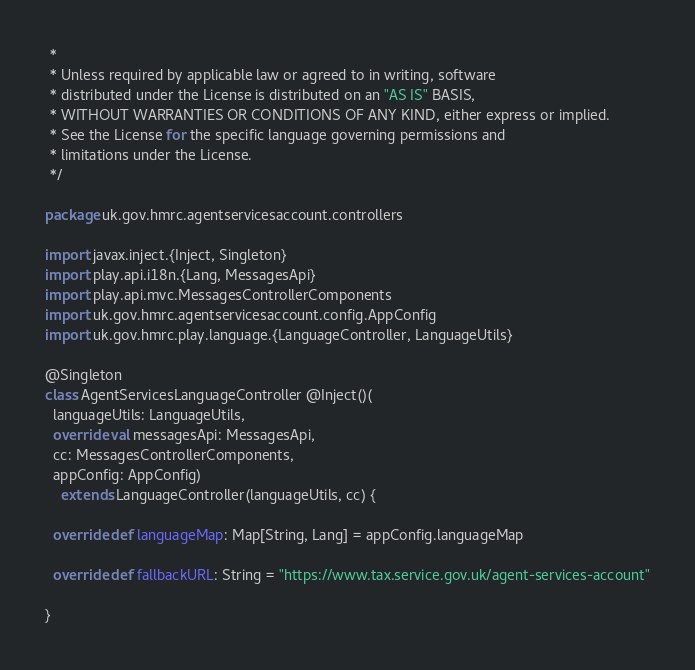<code> <loc_0><loc_0><loc_500><loc_500><_Scala_> *
 * Unless required by applicable law or agreed to in writing, software
 * distributed under the License is distributed on an "AS IS" BASIS,
 * WITHOUT WARRANTIES OR CONDITIONS OF ANY KIND, either express or implied.
 * See the License for the specific language governing permissions and
 * limitations under the License.
 */

package uk.gov.hmrc.agentservicesaccount.controllers

import javax.inject.{Inject, Singleton}
import play.api.i18n.{Lang, MessagesApi}
import play.api.mvc.MessagesControllerComponents
import uk.gov.hmrc.agentservicesaccount.config.AppConfig
import uk.gov.hmrc.play.language.{LanguageController, LanguageUtils}

@Singleton
class AgentServicesLanguageController @Inject()(
  languageUtils: LanguageUtils,
  override val messagesApi: MessagesApi,
  cc: MessagesControllerComponents,
  appConfig: AppConfig)
    extends LanguageController(languageUtils, cc) {

  override def languageMap: Map[String, Lang] = appConfig.languageMap

  override def fallbackURL: String = "https://www.tax.service.gov.uk/agent-services-account"

}
</code> 